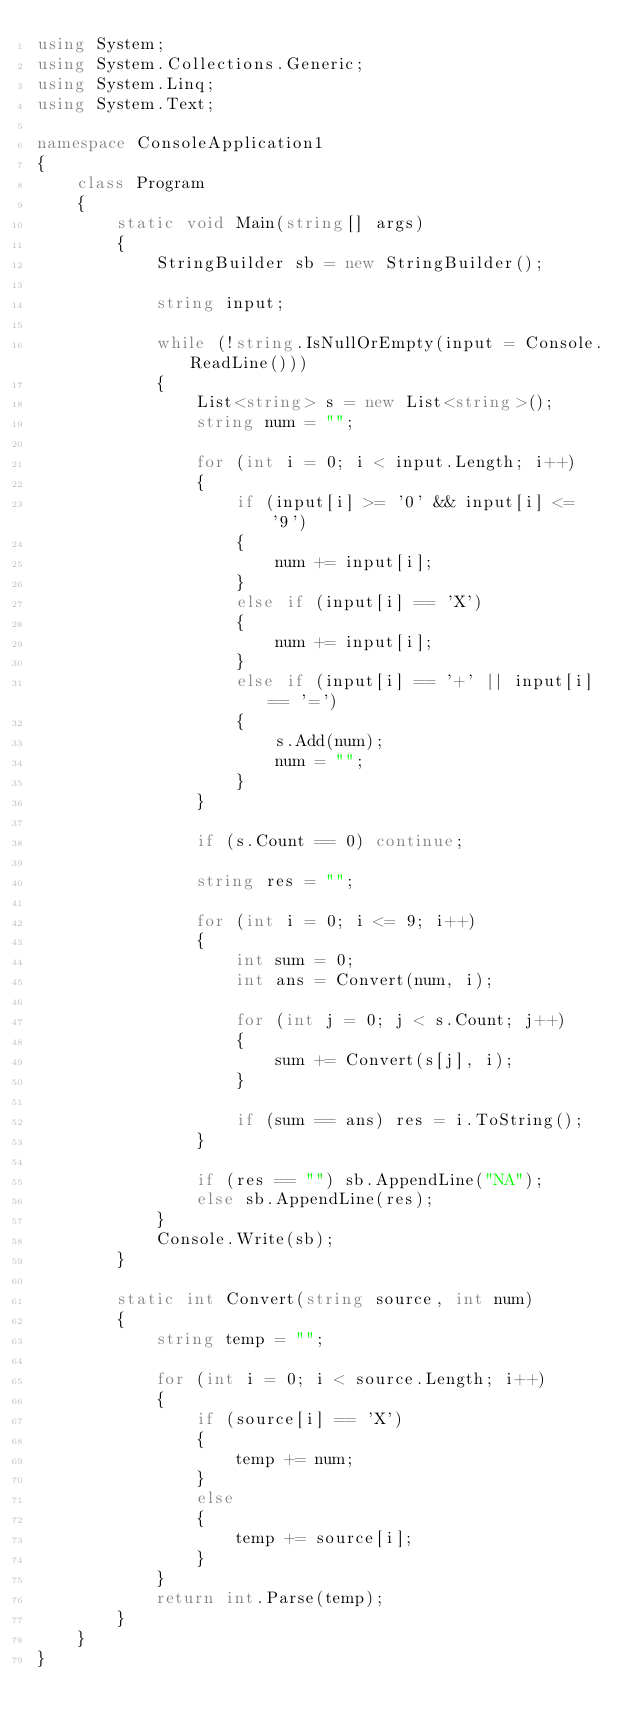Convert code to text. <code><loc_0><loc_0><loc_500><loc_500><_C#_>using System;
using System.Collections.Generic;
using System.Linq;
using System.Text;

namespace ConsoleApplication1
{
    class Program
    {
        static void Main(string[] args)
        {
            StringBuilder sb = new StringBuilder();

            string input;

            while (!string.IsNullOrEmpty(input = Console.ReadLine()))
            {
                List<string> s = new List<string>();
                string num = "";

                for (int i = 0; i < input.Length; i++)
                {
                    if (input[i] >= '0' && input[i] <= '9')
                    {
                        num += input[i];
                    }
                    else if (input[i] == 'X')
                    {
                        num += input[i];
                    }
                    else if (input[i] == '+' || input[i] == '=')
                    {
                        s.Add(num);
                        num = "";
                    }
                }

                if (s.Count == 0) continue;

                string res = "";

                for (int i = 0; i <= 9; i++)
                {
                    int sum = 0;
                    int ans = Convert(num, i);

                    for (int j = 0; j < s.Count; j++)
                    {
                        sum += Convert(s[j], i);
                    }

                    if (sum == ans) res = i.ToString();
                }

                if (res == "") sb.AppendLine("NA");
                else sb.AppendLine(res);
            }
            Console.Write(sb);
        }

        static int Convert(string source, int num)
        {
            string temp = "";

            for (int i = 0; i < source.Length; i++)
            {
                if (source[i] == 'X')
                {
                    temp += num;
                }
                else
                {
                    temp += source[i];
                }
            }
            return int.Parse(temp);
        }
    }
}</code> 